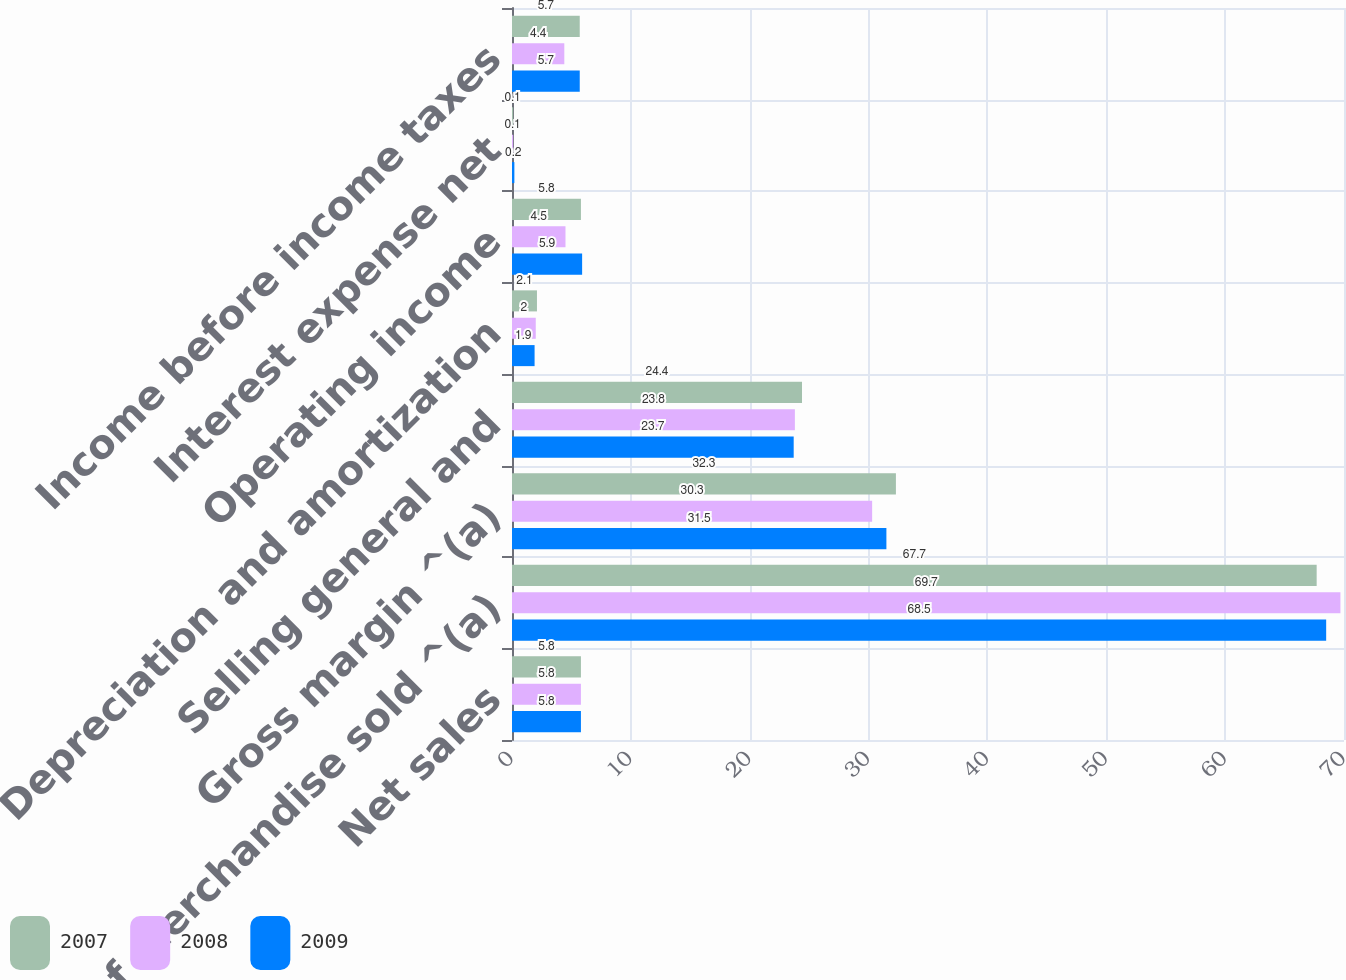Convert chart to OTSL. <chart><loc_0><loc_0><loc_500><loc_500><stacked_bar_chart><ecel><fcel>Net sales<fcel>Cost of merchandise sold ^(a)<fcel>Gross margin ^(a)<fcel>Selling general and<fcel>Depreciation and amortization<fcel>Operating income<fcel>Interest expense net<fcel>Income before income taxes<nl><fcel>2007<fcel>5.8<fcel>67.7<fcel>32.3<fcel>24.4<fcel>2.1<fcel>5.8<fcel>0.1<fcel>5.7<nl><fcel>2008<fcel>5.8<fcel>69.7<fcel>30.3<fcel>23.8<fcel>2<fcel>4.5<fcel>0.1<fcel>4.4<nl><fcel>2009<fcel>5.8<fcel>68.5<fcel>31.5<fcel>23.7<fcel>1.9<fcel>5.9<fcel>0.2<fcel>5.7<nl></chart> 